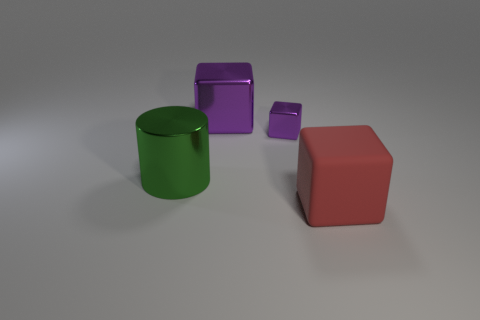Do the purple object that is to the right of the big purple thing and the thing in front of the green object have the same material?
Offer a terse response. No. Are there more tiny purple cubes left of the big purple cube than small purple metallic cubes?
Offer a terse response. No. There is a metallic cube on the right side of the large cube behind the green cylinder; what color is it?
Your answer should be compact. Purple. There is a rubber thing that is the same size as the cylinder; what shape is it?
Offer a very short reply. Cube. What is the shape of the big metal thing that is the same color as the tiny metallic thing?
Your answer should be compact. Cube. Is the number of big red cubes left of the big metal cube the same as the number of large red matte spheres?
Make the answer very short. Yes. What is the big block that is to the right of the big cube that is behind the red rubber object right of the big metal block made of?
Your answer should be compact. Rubber. What is the shape of the other green thing that is made of the same material as the small object?
Your response must be concise. Cylinder. Is there any other thing of the same color as the big matte block?
Make the answer very short. No. There is a metallic cube in front of the large block behind the big red rubber object; what number of metallic things are on the left side of it?
Offer a very short reply. 2. 